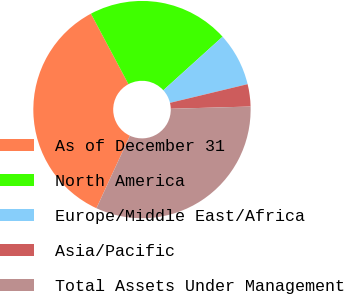Convert chart to OTSL. <chart><loc_0><loc_0><loc_500><loc_500><pie_chart><fcel>As of December 31<fcel>North America<fcel>Europe/Middle East/Africa<fcel>Asia/Pacific<fcel>Total Assets Under Management<nl><fcel>35.33%<fcel>21.08%<fcel>7.94%<fcel>3.31%<fcel>32.33%<nl></chart> 